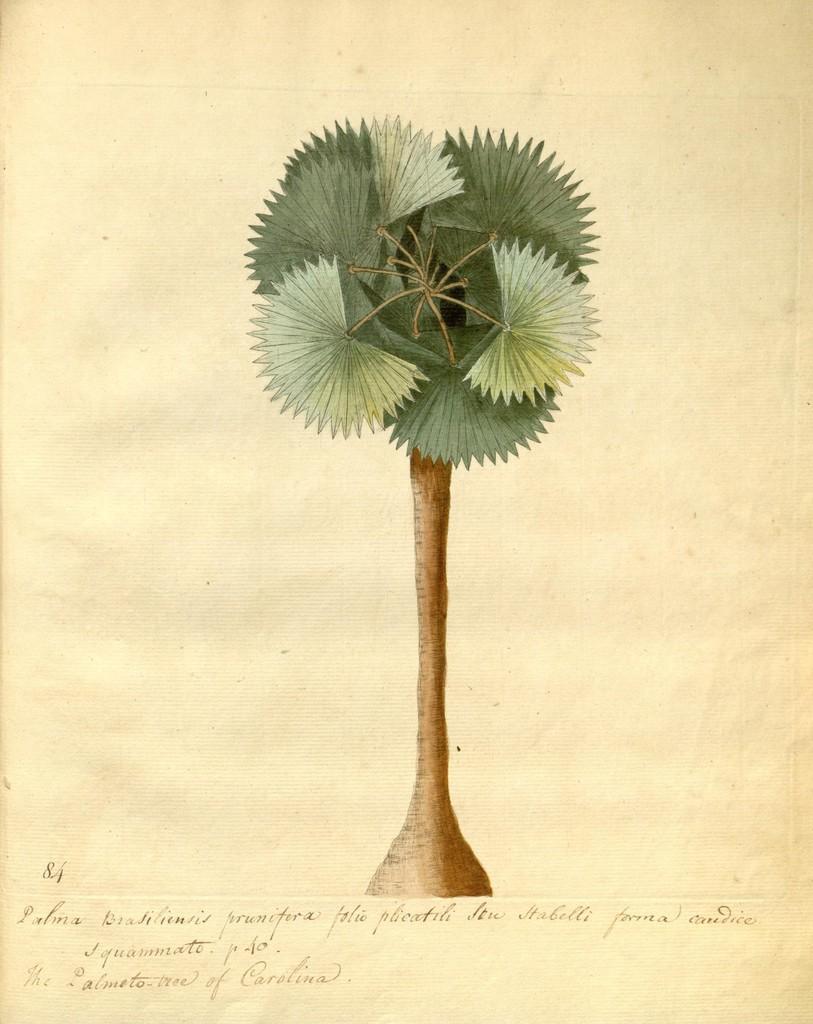Please provide a concise description of this image. In this picture there is a plant poster in the center of the image. 